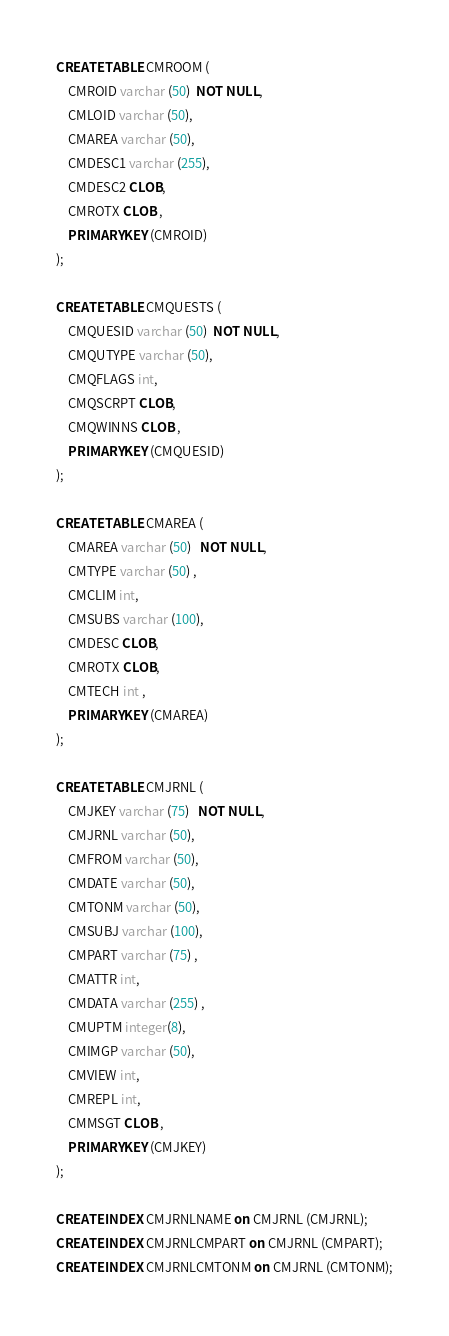<code> <loc_0><loc_0><loc_500><loc_500><_SQL_>
CREATE TABLE CMROOM (
	CMROID varchar (50)  NOT NULL,
	CMLOID varchar (50),
	CMAREA varchar (50),
	CMDESC1 varchar (255),
	CMDESC2 CLOB,
	CMROTX CLOB , 
	PRIMARY KEY (CMROID)
);

CREATE TABLE CMQUESTS (
	CMQUESID varchar (50)  NOT NULL,
	CMQUTYPE varchar (50),
	CMQFLAGS int,
	CMQSCRPT CLOB,
	CMQWINNS CLOB ,
	PRIMARY KEY (CMQUESID)
);

CREATE TABLE CMAREA (
	CMAREA varchar (50)   NOT NULL,
	CMTYPE varchar (50) ,
	CMCLIM int,
	CMSUBS varchar (100),
	CMDESC CLOB,
	CMROTX CLOB,
	CMTECH int ,
	PRIMARY KEY (CMAREA)
);

CREATE TABLE CMJRNL (
	CMJKEY varchar (75)   NOT NULL,
	CMJRNL varchar (50),
	CMFROM varchar (50),
	CMDATE varchar (50),
	CMTONM varchar (50),
	CMSUBJ varchar (100),
	CMPART varchar (75) ,
	CMATTR int,
	CMDATA varchar (255) ,
	CMUPTM integer(8),
	CMIMGP varchar (50),
	CMVIEW int,
	CMREPL int,
	CMMSGT CLOB ,
	PRIMARY KEY (CMJKEY)
);

CREATE INDEX CMJRNLNAME on CMJRNL (CMJRNL);
CREATE INDEX CMJRNLCMPART on CMJRNL (CMPART);
CREATE INDEX CMJRNLCMTONM on CMJRNL (CMTONM);</code> 